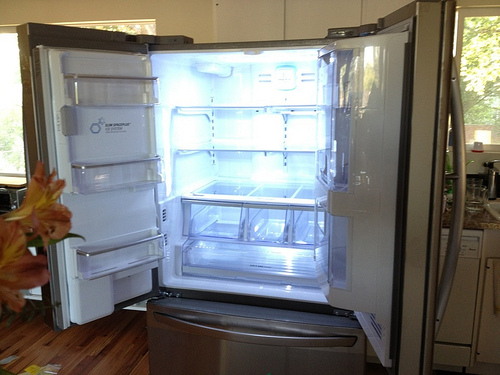Please provide a short description for this region: [0.9, 0.16, 1.0, 0.42]. The described region highlights the vertical span of a large glass window, providing an abundance of natural light and a view into the surrounding environment. 